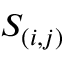Convert formula to latex. <formula><loc_0><loc_0><loc_500><loc_500>S _ { ( i , j ) }</formula> 